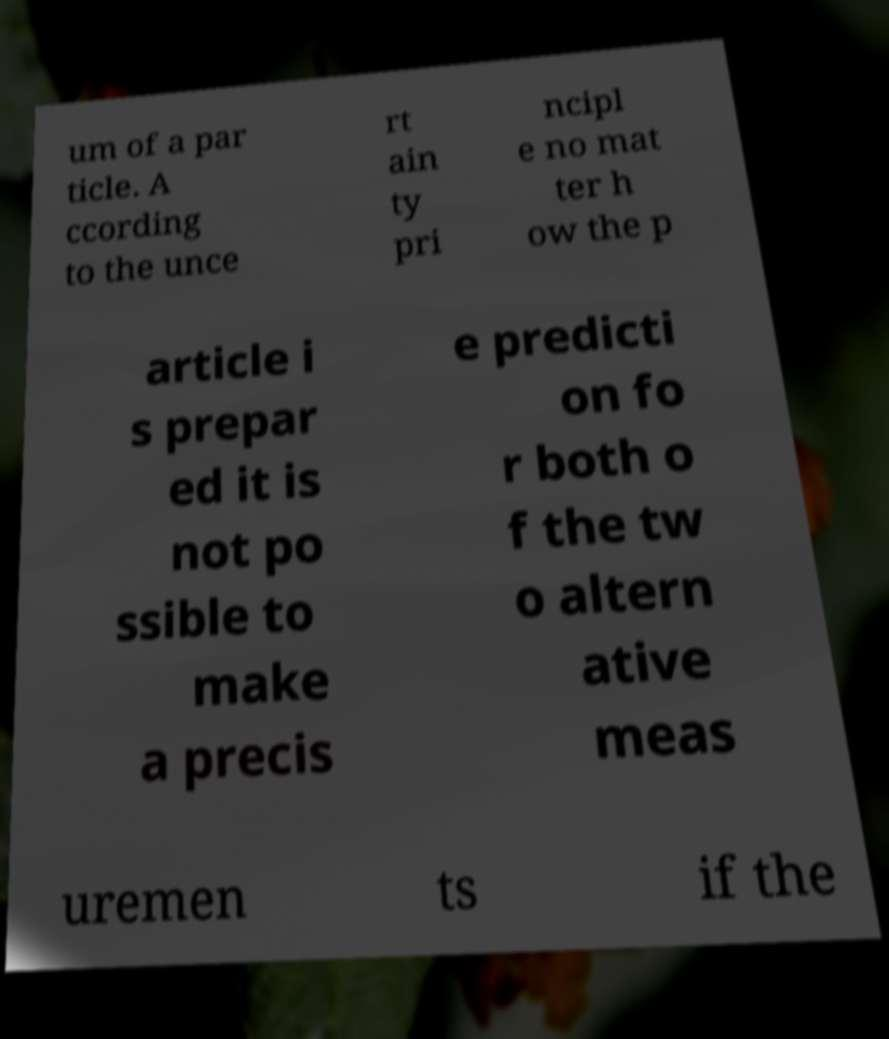Can you accurately transcribe the text from the provided image for me? um of a par ticle. A ccording to the unce rt ain ty pri ncipl e no mat ter h ow the p article i s prepar ed it is not po ssible to make a precis e predicti on fo r both o f the tw o altern ative meas uremen ts if the 